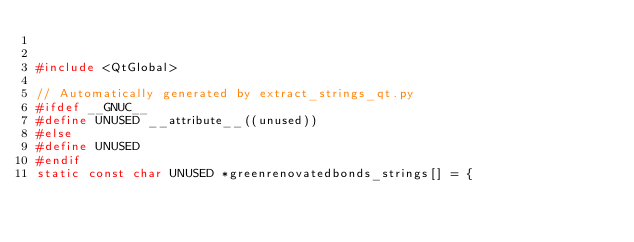<code> <loc_0><loc_0><loc_500><loc_500><_C++_>

#include <QtGlobal>

// Automatically generated by extract_strings_qt.py
#ifdef __GNUC__
#define UNUSED __attribute__((unused))
#else
#define UNUSED
#endif
static const char UNUSED *greenrenovatedbonds_strings[] = {</code> 